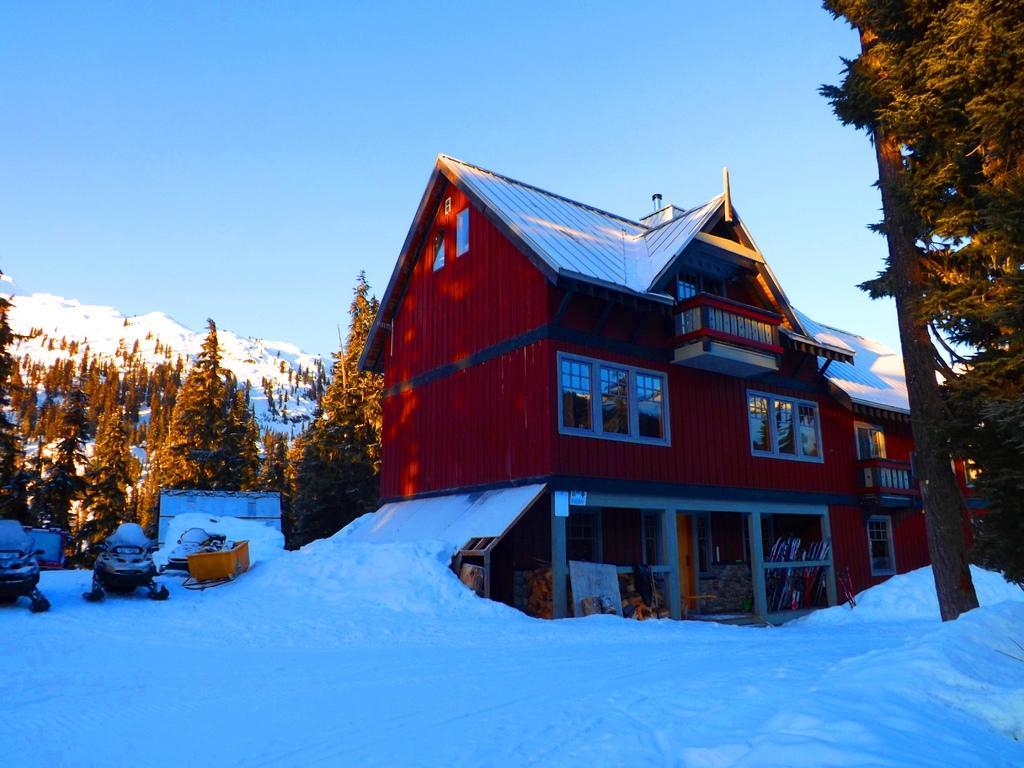How would you summarize this image in a sentence or two? In this image there are trees and houses. On the surface there is snow, beside the house there are snow bikes parked. In the background of the image there are snowy mountains. 